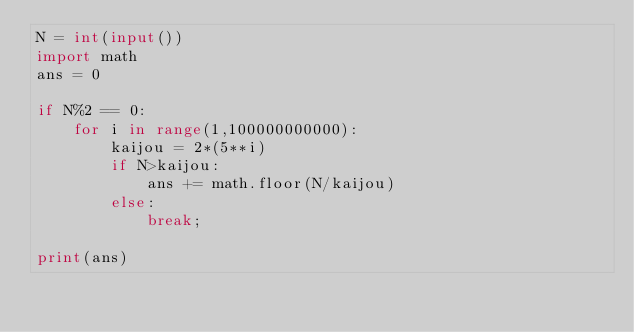Convert code to text. <code><loc_0><loc_0><loc_500><loc_500><_Python_>N = int(input())
import math
ans = 0

if N%2 == 0:
    for i in range(1,100000000000):
        kaijou = 2*(5**i)
        if N>kaijou:
            ans += math.floor(N/kaijou)
        else:
            break;

print(ans)</code> 